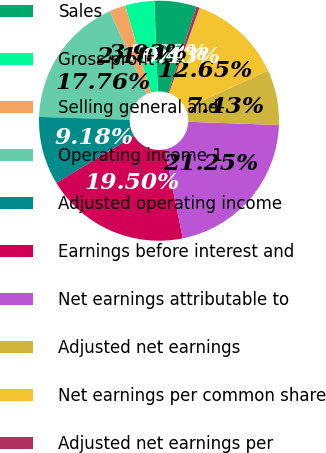Convert chart to OTSL. <chart><loc_0><loc_0><loc_500><loc_500><pie_chart><fcel>Sales<fcel>Gross profit<fcel>Selling general and<fcel>Operating income 1<fcel>Adjusted operating income<fcel>Earnings before interest and<fcel>Net earnings attributable to<fcel>Adjusted net earnings<fcel>Net earnings per common share<fcel>Adjusted net earnings per<nl><fcel>5.68%<fcel>3.93%<fcel>2.18%<fcel>17.76%<fcel>9.18%<fcel>19.5%<fcel>21.25%<fcel>7.43%<fcel>12.65%<fcel>0.43%<nl></chart> 